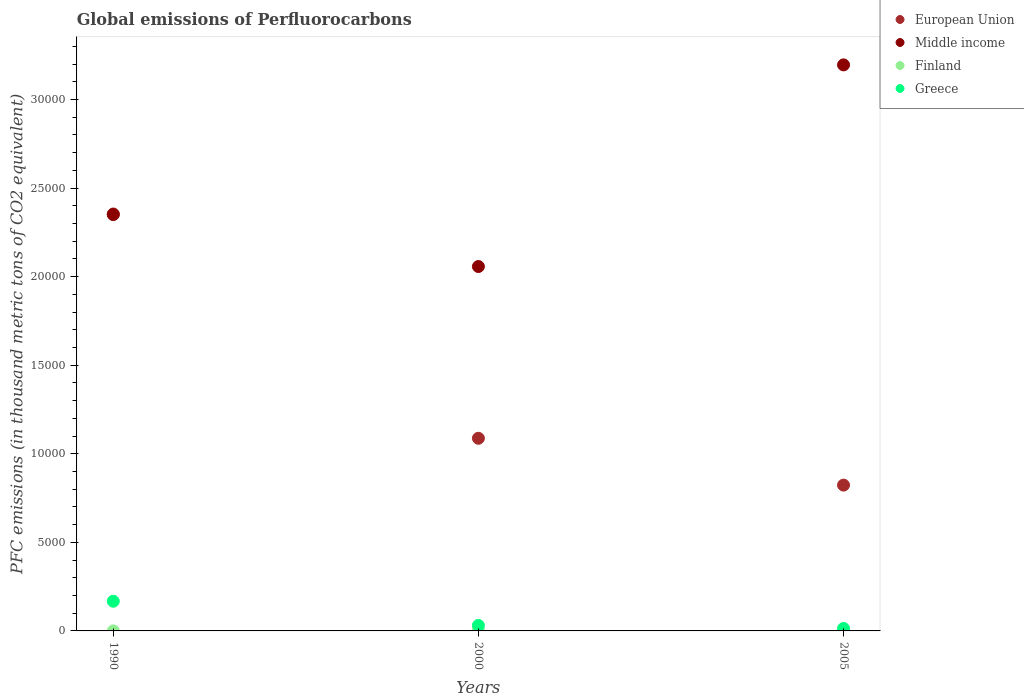What is the global emissions of Perfluorocarbons in Middle income in 2005?
Your answer should be compact. 3.20e+04. Across all years, what is the maximum global emissions of Perfluorocarbons in Finland?
Ensure brevity in your answer.  29.7. Across all years, what is the minimum global emissions of Perfluorocarbons in Middle income?
Offer a terse response. 2.06e+04. In which year was the global emissions of Perfluorocarbons in Greece maximum?
Ensure brevity in your answer.  1990. In which year was the global emissions of Perfluorocarbons in Finland minimum?
Your response must be concise. 1990. What is the total global emissions of Perfluorocarbons in Finland in the graph?
Your answer should be very brief. 48.1. What is the difference between the global emissions of Perfluorocarbons in European Union in 1990 and that in 2005?
Your answer should be compact. 1.53e+04. What is the difference between the global emissions of Perfluorocarbons in Middle income in 1990 and the global emissions of Perfluorocarbons in Greece in 2000?
Your answer should be compact. 2.32e+04. What is the average global emissions of Perfluorocarbons in Middle income per year?
Your response must be concise. 2.53e+04. In the year 2005, what is the difference between the global emissions of Perfluorocarbons in European Union and global emissions of Perfluorocarbons in Middle income?
Your answer should be compact. -2.37e+04. What is the ratio of the global emissions of Perfluorocarbons in Finland in 1990 to that in 2000?
Offer a very short reply. 0.06. Is the global emissions of Perfluorocarbons in Greece in 2000 less than that in 2005?
Offer a very short reply. No. Is the difference between the global emissions of Perfluorocarbons in European Union in 1990 and 2005 greater than the difference between the global emissions of Perfluorocarbons in Middle income in 1990 and 2005?
Ensure brevity in your answer.  Yes. What is the difference between the highest and the second highest global emissions of Perfluorocarbons in Finland?
Provide a succinct answer. 13. What is the difference between the highest and the lowest global emissions of Perfluorocarbons in European Union?
Offer a terse response. 1.53e+04. In how many years, is the global emissions of Perfluorocarbons in Middle income greater than the average global emissions of Perfluorocarbons in Middle income taken over all years?
Your answer should be compact. 1. Is the sum of the global emissions of Perfluorocarbons in Greece in 1990 and 2000 greater than the maximum global emissions of Perfluorocarbons in Middle income across all years?
Offer a terse response. No. Is it the case that in every year, the sum of the global emissions of Perfluorocarbons in Finland and global emissions of Perfluorocarbons in Middle income  is greater than the sum of global emissions of Perfluorocarbons in European Union and global emissions of Perfluorocarbons in Greece?
Keep it short and to the point. No. Is it the case that in every year, the sum of the global emissions of Perfluorocarbons in Finland and global emissions of Perfluorocarbons in Middle income  is greater than the global emissions of Perfluorocarbons in European Union?
Your answer should be compact. No. Is the global emissions of Perfluorocarbons in Middle income strictly greater than the global emissions of Perfluorocarbons in European Union over the years?
Your response must be concise. No. Is the global emissions of Perfluorocarbons in European Union strictly less than the global emissions of Perfluorocarbons in Greece over the years?
Offer a terse response. No. How many dotlines are there?
Your response must be concise. 4. How many years are there in the graph?
Your answer should be compact. 3. What is the difference between two consecutive major ticks on the Y-axis?
Keep it short and to the point. 5000. Are the values on the major ticks of Y-axis written in scientific E-notation?
Your answer should be very brief. No. Does the graph contain any zero values?
Give a very brief answer. No. Does the graph contain grids?
Keep it short and to the point. No. Where does the legend appear in the graph?
Offer a very short reply. Top right. How many legend labels are there?
Offer a terse response. 4. How are the legend labels stacked?
Make the answer very short. Vertical. What is the title of the graph?
Provide a short and direct response. Global emissions of Perfluorocarbons. What is the label or title of the Y-axis?
Offer a very short reply. PFC emissions (in thousand metric tons of CO2 equivalent). What is the PFC emissions (in thousand metric tons of CO2 equivalent) of European Union in 1990?
Provide a succinct answer. 2.35e+04. What is the PFC emissions (in thousand metric tons of CO2 equivalent) of Middle income in 1990?
Offer a terse response. 2.35e+04. What is the PFC emissions (in thousand metric tons of CO2 equivalent) in Greece in 1990?
Your answer should be very brief. 1675.9. What is the PFC emissions (in thousand metric tons of CO2 equivalent) in European Union in 2000?
Your response must be concise. 1.09e+04. What is the PFC emissions (in thousand metric tons of CO2 equivalent) in Middle income in 2000?
Your answer should be very brief. 2.06e+04. What is the PFC emissions (in thousand metric tons of CO2 equivalent) in Finland in 2000?
Ensure brevity in your answer.  29.7. What is the PFC emissions (in thousand metric tons of CO2 equivalent) in Greece in 2000?
Ensure brevity in your answer.  311.3. What is the PFC emissions (in thousand metric tons of CO2 equivalent) of European Union in 2005?
Provide a succinct answer. 8230.79. What is the PFC emissions (in thousand metric tons of CO2 equivalent) of Middle income in 2005?
Your response must be concise. 3.20e+04. What is the PFC emissions (in thousand metric tons of CO2 equivalent) of Finland in 2005?
Your answer should be compact. 16.7. What is the PFC emissions (in thousand metric tons of CO2 equivalent) of Greece in 2005?
Keep it short and to the point. 137.5. Across all years, what is the maximum PFC emissions (in thousand metric tons of CO2 equivalent) of European Union?
Give a very brief answer. 2.35e+04. Across all years, what is the maximum PFC emissions (in thousand metric tons of CO2 equivalent) of Middle income?
Give a very brief answer. 3.20e+04. Across all years, what is the maximum PFC emissions (in thousand metric tons of CO2 equivalent) of Finland?
Offer a very short reply. 29.7. Across all years, what is the maximum PFC emissions (in thousand metric tons of CO2 equivalent) in Greece?
Offer a very short reply. 1675.9. Across all years, what is the minimum PFC emissions (in thousand metric tons of CO2 equivalent) of European Union?
Your response must be concise. 8230.79. Across all years, what is the minimum PFC emissions (in thousand metric tons of CO2 equivalent) of Middle income?
Your response must be concise. 2.06e+04. Across all years, what is the minimum PFC emissions (in thousand metric tons of CO2 equivalent) in Finland?
Offer a terse response. 1.7. Across all years, what is the minimum PFC emissions (in thousand metric tons of CO2 equivalent) in Greece?
Provide a short and direct response. 137.5. What is the total PFC emissions (in thousand metric tons of CO2 equivalent) in European Union in the graph?
Your answer should be very brief. 4.26e+04. What is the total PFC emissions (in thousand metric tons of CO2 equivalent) in Middle income in the graph?
Offer a terse response. 7.60e+04. What is the total PFC emissions (in thousand metric tons of CO2 equivalent) of Finland in the graph?
Your answer should be very brief. 48.1. What is the total PFC emissions (in thousand metric tons of CO2 equivalent) in Greece in the graph?
Provide a short and direct response. 2124.7. What is the difference between the PFC emissions (in thousand metric tons of CO2 equivalent) in European Union in 1990 and that in 2000?
Ensure brevity in your answer.  1.27e+04. What is the difference between the PFC emissions (in thousand metric tons of CO2 equivalent) of Middle income in 1990 and that in 2000?
Offer a terse response. 2931.5. What is the difference between the PFC emissions (in thousand metric tons of CO2 equivalent) of Greece in 1990 and that in 2000?
Your answer should be very brief. 1364.6. What is the difference between the PFC emissions (in thousand metric tons of CO2 equivalent) in European Union in 1990 and that in 2005?
Offer a very short reply. 1.53e+04. What is the difference between the PFC emissions (in thousand metric tons of CO2 equivalent) in Middle income in 1990 and that in 2005?
Offer a very short reply. -8451.4. What is the difference between the PFC emissions (in thousand metric tons of CO2 equivalent) in Finland in 1990 and that in 2005?
Provide a succinct answer. -15. What is the difference between the PFC emissions (in thousand metric tons of CO2 equivalent) of Greece in 1990 and that in 2005?
Ensure brevity in your answer.  1538.4. What is the difference between the PFC emissions (in thousand metric tons of CO2 equivalent) in European Union in 2000 and that in 2005?
Make the answer very short. 2643.81. What is the difference between the PFC emissions (in thousand metric tons of CO2 equivalent) in Middle income in 2000 and that in 2005?
Provide a short and direct response. -1.14e+04. What is the difference between the PFC emissions (in thousand metric tons of CO2 equivalent) of Greece in 2000 and that in 2005?
Provide a short and direct response. 173.8. What is the difference between the PFC emissions (in thousand metric tons of CO2 equivalent) of European Union in 1990 and the PFC emissions (in thousand metric tons of CO2 equivalent) of Middle income in 2000?
Give a very brief answer. 2966.1. What is the difference between the PFC emissions (in thousand metric tons of CO2 equivalent) in European Union in 1990 and the PFC emissions (in thousand metric tons of CO2 equivalent) in Finland in 2000?
Make the answer very short. 2.35e+04. What is the difference between the PFC emissions (in thousand metric tons of CO2 equivalent) of European Union in 1990 and the PFC emissions (in thousand metric tons of CO2 equivalent) of Greece in 2000?
Make the answer very short. 2.32e+04. What is the difference between the PFC emissions (in thousand metric tons of CO2 equivalent) in Middle income in 1990 and the PFC emissions (in thousand metric tons of CO2 equivalent) in Finland in 2000?
Provide a short and direct response. 2.35e+04. What is the difference between the PFC emissions (in thousand metric tons of CO2 equivalent) in Middle income in 1990 and the PFC emissions (in thousand metric tons of CO2 equivalent) in Greece in 2000?
Your answer should be compact. 2.32e+04. What is the difference between the PFC emissions (in thousand metric tons of CO2 equivalent) in Finland in 1990 and the PFC emissions (in thousand metric tons of CO2 equivalent) in Greece in 2000?
Your response must be concise. -309.6. What is the difference between the PFC emissions (in thousand metric tons of CO2 equivalent) in European Union in 1990 and the PFC emissions (in thousand metric tons of CO2 equivalent) in Middle income in 2005?
Give a very brief answer. -8416.8. What is the difference between the PFC emissions (in thousand metric tons of CO2 equivalent) in European Union in 1990 and the PFC emissions (in thousand metric tons of CO2 equivalent) in Finland in 2005?
Ensure brevity in your answer.  2.35e+04. What is the difference between the PFC emissions (in thousand metric tons of CO2 equivalent) in European Union in 1990 and the PFC emissions (in thousand metric tons of CO2 equivalent) in Greece in 2005?
Your answer should be very brief. 2.34e+04. What is the difference between the PFC emissions (in thousand metric tons of CO2 equivalent) of Middle income in 1990 and the PFC emissions (in thousand metric tons of CO2 equivalent) of Finland in 2005?
Offer a very short reply. 2.35e+04. What is the difference between the PFC emissions (in thousand metric tons of CO2 equivalent) in Middle income in 1990 and the PFC emissions (in thousand metric tons of CO2 equivalent) in Greece in 2005?
Provide a succinct answer. 2.34e+04. What is the difference between the PFC emissions (in thousand metric tons of CO2 equivalent) in Finland in 1990 and the PFC emissions (in thousand metric tons of CO2 equivalent) in Greece in 2005?
Make the answer very short. -135.8. What is the difference between the PFC emissions (in thousand metric tons of CO2 equivalent) of European Union in 2000 and the PFC emissions (in thousand metric tons of CO2 equivalent) of Middle income in 2005?
Give a very brief answer. -2.11e+04. What is the difference between the PFC emissions (in thousand metric tons of CO2 equivalent) in European Union in 2000 and the PFC emissions (in thousand metric tons of CO2 equivalent) in Finland in 2005?
Offer a terse response. 1.09e+04. What is the difference between the PFC emissions (in thousand metric tons of CO2 equivalent) in European Union in 2000 and the PFC emissions (in thousand metric tons of CO2 equivalent) in Greece in 2005?
Keep it short and to the point. 1.07e+04. What is the difference between the PFC emissions (in thousand metric tons of CO2 equivalent) of Middle income in 2000 and the PFC emissions (in thousand metric tons of CO2 equivalent) of Finland in 2005?
Provide a succinct answer. 2.06e+04. What is the difference between the PFC emissions (in thousand metric tons of CO2 equivalent) in Middle income in 2000 and the PFC emissions (in thousand metric tons of CO2 equivalent) in Greece in 2005?
Your answer should be very brief. 2.04e+04. What is the difference between the PFC emissions (in thousand metric tons of CO2 equivalent) of Finland in 2000 and the PFC emissions (in thousand metric tons of CO2 equivalent) of Greece in 2005?
Make the answer very short. -107.8. What is the average PFC emissions (in thousand metric tons of CO2 equivalent) in European Union per year?
Offer a very short reply. 1.42e+04. What is the average PFC emissions (in thousand metric tons of CO2 equivalent) of Middle income per year?
Offer a very short reply. 2.53e+04. What is the average PFC emissions (in thousand metric tons of CO2 equivalent) in Finland per year?
Provide a short and direct response. 16.03. What is the average PFC emissions (in thousand metric tons of CO2 equivalent) of Greece per year?
Make the answer very short. 708.23. In the year 1990, what is the difference between the PFC emissions (in thousand metric tons of CO2 equivalent) in European Union and PFC emissions (in thousand metric tons of CO2 equivalent) in Middle income?
Ensure brevity in your answer.  34.6. In the year 1990, what is the difference between the PFC emissions (in thousand metric tons of CO2 equivalent) of European Union and PFC emissions (in thousand metric tons of CO2 equivalent) of Finland?
Your answer should be very brief. 2.35e+04. In the year 1990, what is the difference between the PFC emissions (in thousand metric tons of CO2 equivalent) in European Union and PFC emissions (in thousand metric tons of CO2 equivalent) in Greece?
Provide a short and direct response. 2.19e+04. In the year 1990, what is the difference between the PFC emissions (in thousand metric tons of CO2 equivalent) in Middle income and PFC emissions (in thousand metric tons of CO2 equivalent) in Finland?
Give a very brief answer. 2.35e+04. In the year 1990, what is the difference between the PFC emissions (in thousand metric tons of CO2 equivalent) of Middle income and PFC emissions (in thousand metric tons of CO2 equivalent) of Greece?
Ensure brevity in your answer.  2.18e+04. In the year 1990, what is the difference between the PFC emissions (in thousand metric tons of CO2 equivalent) in Finland and PFC emissions (in thousand metric tons of CO2 equivalent) in Greece?
Provide a short and direct response. -1674.2. In the year 2000, what is the difference between the PFC emissions (in thousand metric tons of CO2 equivalent) of European Union and PFC emissions (in thousand metric tons of CO2 equivalent) of Middle income?
Keep it short and to the point. -9695.8. In the year 2000, what is the difference between the PFC emissions (in thousand metric tons of CO2 equivalent) in European Union and PFC emissions (in thousand metric tons of CO2 equivalent) in Finland?
Ensure brevity in your answer.  1.08e+04. In the year 2000, what is the difference between the PFC emissions (in thousand metric tons of CO2 equivalent) in European Union and PFC emissions (in thousand metric tons of CO2 equivalent) in Greece?
Your answer should be very brief. 1.06e+04. In the year 2000, what is the difference between the PFC emissions (in thousand metric tons of CO2 equivalent) of Middle income and PFC emissions (in thousand metric tons of CO2 equivalent) of Finland?
Your response must be concise. 2.05e+04. In the year 2000, what is the difference between the PFC emissions (in thousand metric tons of CO2 equivalent) in Middle income and PFC emissions (in thousand metric tons of CO2 equivalent) in Greece?
Offer a very short reply. 2.03e+04. In the year 2000, what is the difference between the PFC emissions (in thousand metric tons of CO2 equivalent) of Finland and PFC emissions (in thousand metric tons of CO2 equivalent) of Greece?
Provide a short and direct response. -281.6. In the year 2005, what is the difference between the PFC emissions (in thousand metric tons of CO2 equivalent) in European Union and PFC emissions (in thousand metric tons of CO2 equivalent) in Middle income?
Give a very brief answer. -2.37e+04. In the year 2005, what is the difference between the PFC emissions (in thousand metric tons of CO2 equivalent) in European Union and PFC emissions (in thousand metric tons of CO2 equivalent) in Finland?
Provide a short and direct response. 8214.09. In the year 2005, what is the difference between the PFC emissions (in thousand metric tons of CO2 equivalent) of European Union and PFC emissions (in thousand metric tons of CO2 equivalent) of Greece?
Keep it short and to the point. 8093.29. In the year 2005, what is the difference between the PFC emissions (in thousand metric tons of CO2 equivalent) of Middle income and PFC emissions (in thousand metric tons of CO2 equivalent) of Finland?
Provide a short and direct response. 3.19e+04. In the year 2005, what is the difference between the PFC emissions (in thousand metric tons of CO2 equivalent) of Middle income and PFC emissions (in thousand metric tons of CO2 equivalent) of Greece?
Your response must be concise. 3.18e+04. In the year 2005, what is the difference between the PFC emissions (in thousand metric tons of CO2 equivalent) in Finland and PFC emissions (in thousand metric tons of CO2 equivalent) in Greece?
Keep it short and to the point. -120.8. What is the ratio of the PFC emissions (in thousand metric tons of CO2 equivalent) of European Union in 1990 to that in 2000?
Make the answer very short. 2.16. What is the ratio of the PFC emissions (in thousand metric tons of CO2 equivalent) of Middle income in 1990 to that in 2000?
Offer a terse response. 1.14. What is the ratio of the PFC emissions (in thousand metric tons of CO2 equivalent) of Finland in 1990 to that in 2000?
Ensure brevity in your answer.  0.06. What is the ratio of the PFC emissions (in thousand metric tons of CO2 equivalent) in Greece in 1990 to that in 2000?
Make the answer very short. 5.38. What is the ratio of the PFC emissions (in thousand metric tons of CO2 equivalent) in European Union in 1990 to that in 2005?
Your answer should be very brief. 2.86. What is the ratio of the PFC emissions (in thousand metric tons of CO2 equivalent) in Middle income in 1990 to that in 2005?
Keep it short and to the point. 0.74. What is the ratio of the PFC emissions (in thousand metric tons of CO2 equivalent) in Finland in 1990 to that in 2005?
Your answer should be very brief. 0.1. What is the ratio of the PFC emissions (in thousand metric tons of CO2 equivalent) in Greece in 1990 to that in 2005?
Provide a succinct answer. 12.19. What is the ratio of the PFC emissions (in thousand metric tons of CO2 equivalent) of European Union in 2000 to that in 2005?
Make the answer very short. 1.32. What is the ratio of the PFC emissions (in thousand metric tons of CO2 equivalent) in Middle income in 2000 to that in 2005?
Make the answer very short. 0.64. What is the ratio of the PFC emissions (in thousand metric tons of CO2 equivalent) of Finland in 2000 to that in 2005?
Your answer should be very brief. 1.78. What is the ratio of the PFC emissions (in thousand metric tons of CO2 equivalent) of Greece in 2000 to that in 2005?
Keep it short and to the point. 2.26. What is the difference between the highest and the second highest PFC emissions (in thousand metric tons of CO2 equivalent) of European Union?
Make the answer very short. 1.27e+04. What is the difference between the highest and the second highest PFC emissions (in thousand metric tons of CO2 equivalent) in Middle income?
Give a very brief answer. 8451.4. What is the difference between the highest and the second highest PFC emissions (in thousand metric tons of CO2 equivalent) in Finland?
Your answer should be very brief. 13. What is the difference between the highest and the second highest PFC emissions (in thousand metric tons of CO2 equivalent) in Greece?
Offer a very short reply. 1364.6. What is the difference between the highest and the lowest PFC emissions (in thousand metric tons of CO2 equivalent) in European Union?
Offer a very short reply. 1.53e+04. What is the difference between the highest and the lowest PFC emissions (in thousand metric tons of CO2 equivalent) of Middle income?
Make the answer very short. 1.14e+04. What is the difference between the highest and the lowest PFC emissions (in thousand metric tons of CO2 equivalent) of Greece?
Provide a succinct answer. 1538.4. 